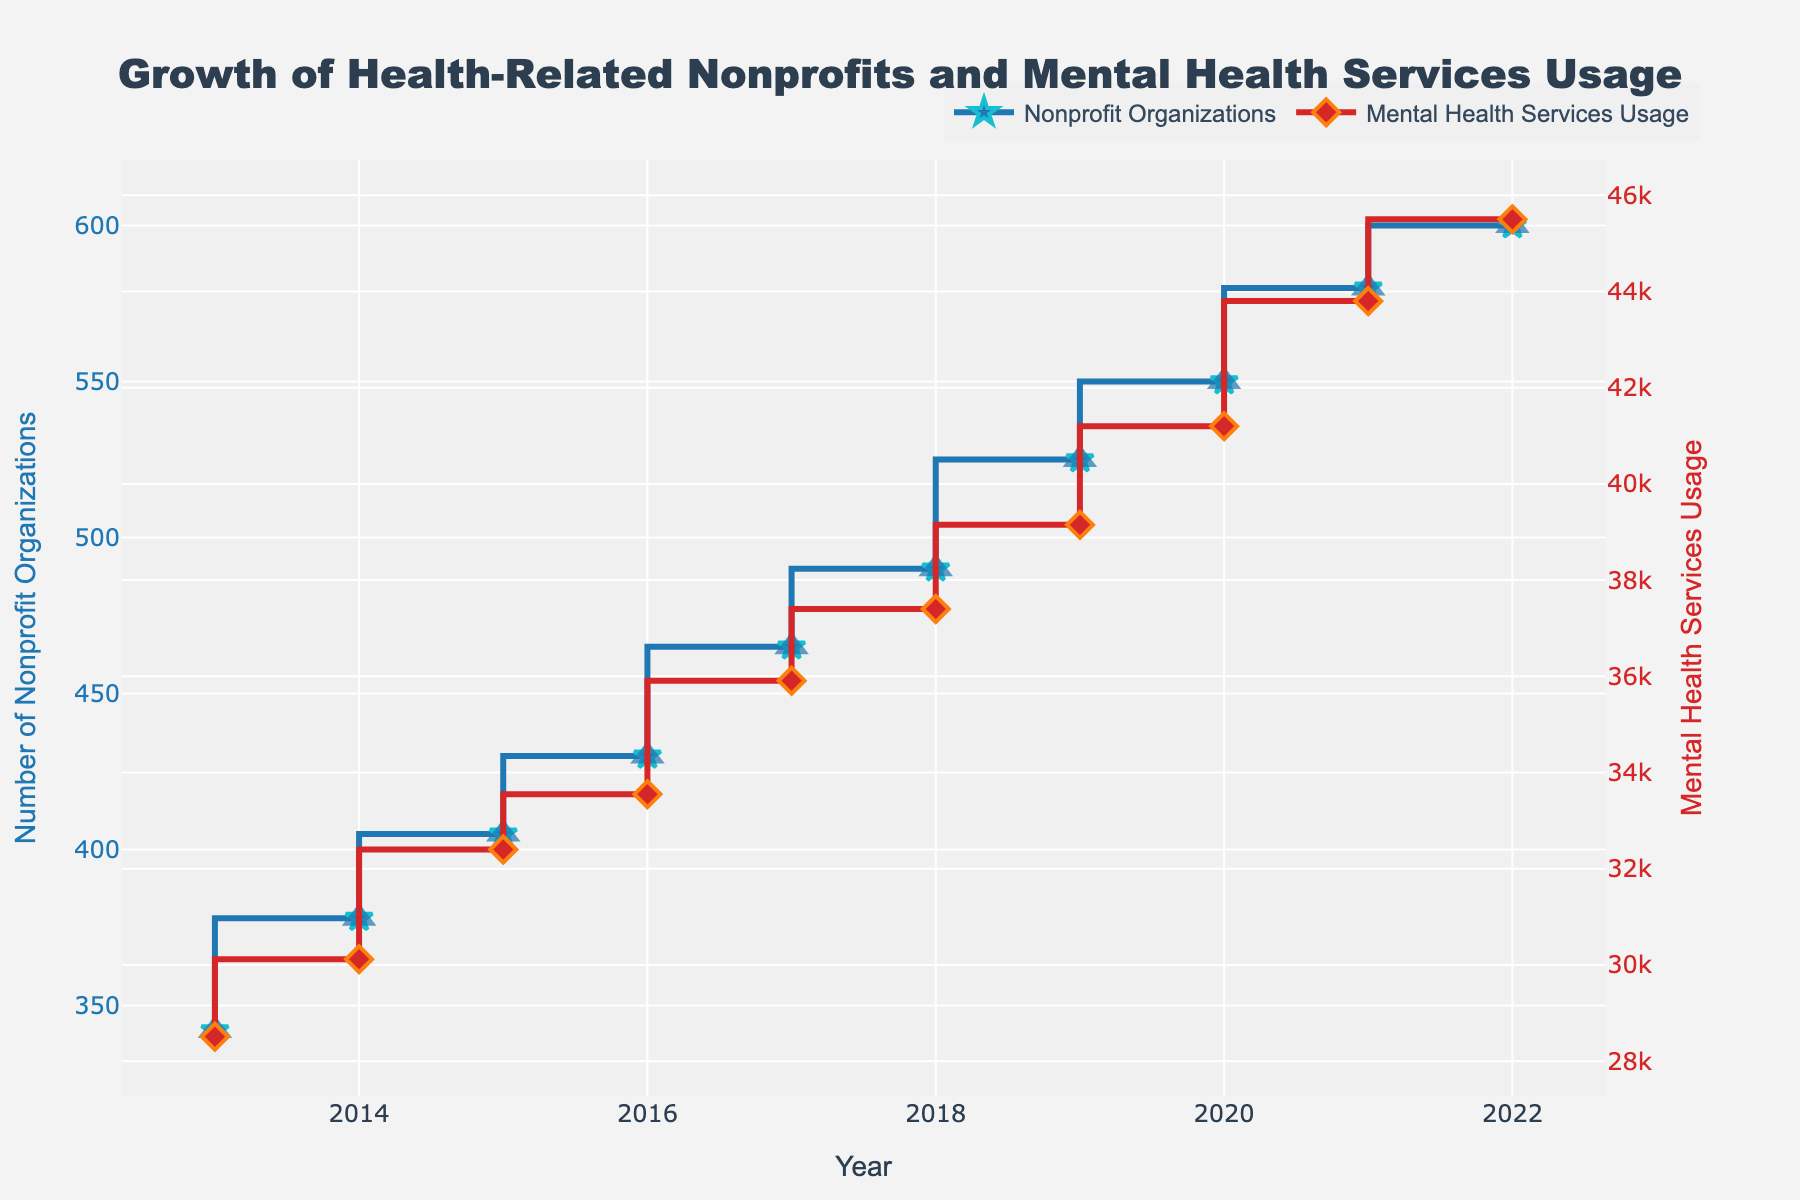What is the title of the figure? The title of the figure is displayed prominently at the top and reads "Growth of Health-Related Nonprofits and Mental Health Services Usage".
Answer: Growth of Health-Related Nonprofits and Mental Health Services Usage How many data points are present for each variable in the figure? By counting the markers or data points on each line, we can see there are 10 data points for both Nonprofit Organizations and Mental Health Services Usage.
Answer: 10 Which year saw the highest number of nonprofit organizations? The highest point on the blue stair line representing Nonprofit Organizations is in the year 2022. The data for that year is the highest at 600.
Answer: 2022 What is the trend in the mental health services usage from 2013 to 2022? Observing the red stair line for Mental Health Services Usage from left to right, there is a consistent upward trend, indicating increasing usage.
Answer: Increasing By how much did the number of nonprofit organizations increase from 2013 to 2022? The number of nonprofit organizations in 2013 was 342, and it increased to 600 in 2022. The difference is 600 - 342 = 258.
Answer: 258 In which year did mental health services usage first exceed 40,000? By looking at the red stair line, mental health services usage first exceeded 40,000 in 2020. The usage shown for 2020 is 41,200.
Answer: 2020 Compare the growth rates of nonprofit organizations and mental health services usage from 2013 to 2022. Which grew faster? To compare the growth rates, calculate the difference from 2013 to 2022 for both variables: Nonprofits increased by 258 (600-342), and Mental Health Services Usage increased by 16,990 (45500-28510). Mental Health Services Usage grew faster.
Answer: Mental Health Services Usage What is the increment in mental health services usage from 2019 to 2020? In 2019, Mental Health Services Usage was 39,150. In 2020, it increased to 41,200. The increment is 41,200 - 39,150 = 2,050.
Answer: 2,050 Which year saw the smallest increase in nonprofit organizations, and by how much did it increase? By checking the differences year over year on the blue line, the smallest increase happened between 2021 and 2022, where it only increased by 20 (600-580).
Answer: 2021-2022, 20 What were the respective values of nonprofit organizations and mental health services usage in 2016? By looking at the points on the lines corresponding to 2016: Nonprofit Organizations were 430 and Mental Health Services Usage was 33,550.
Answer: 430 and 33,550 